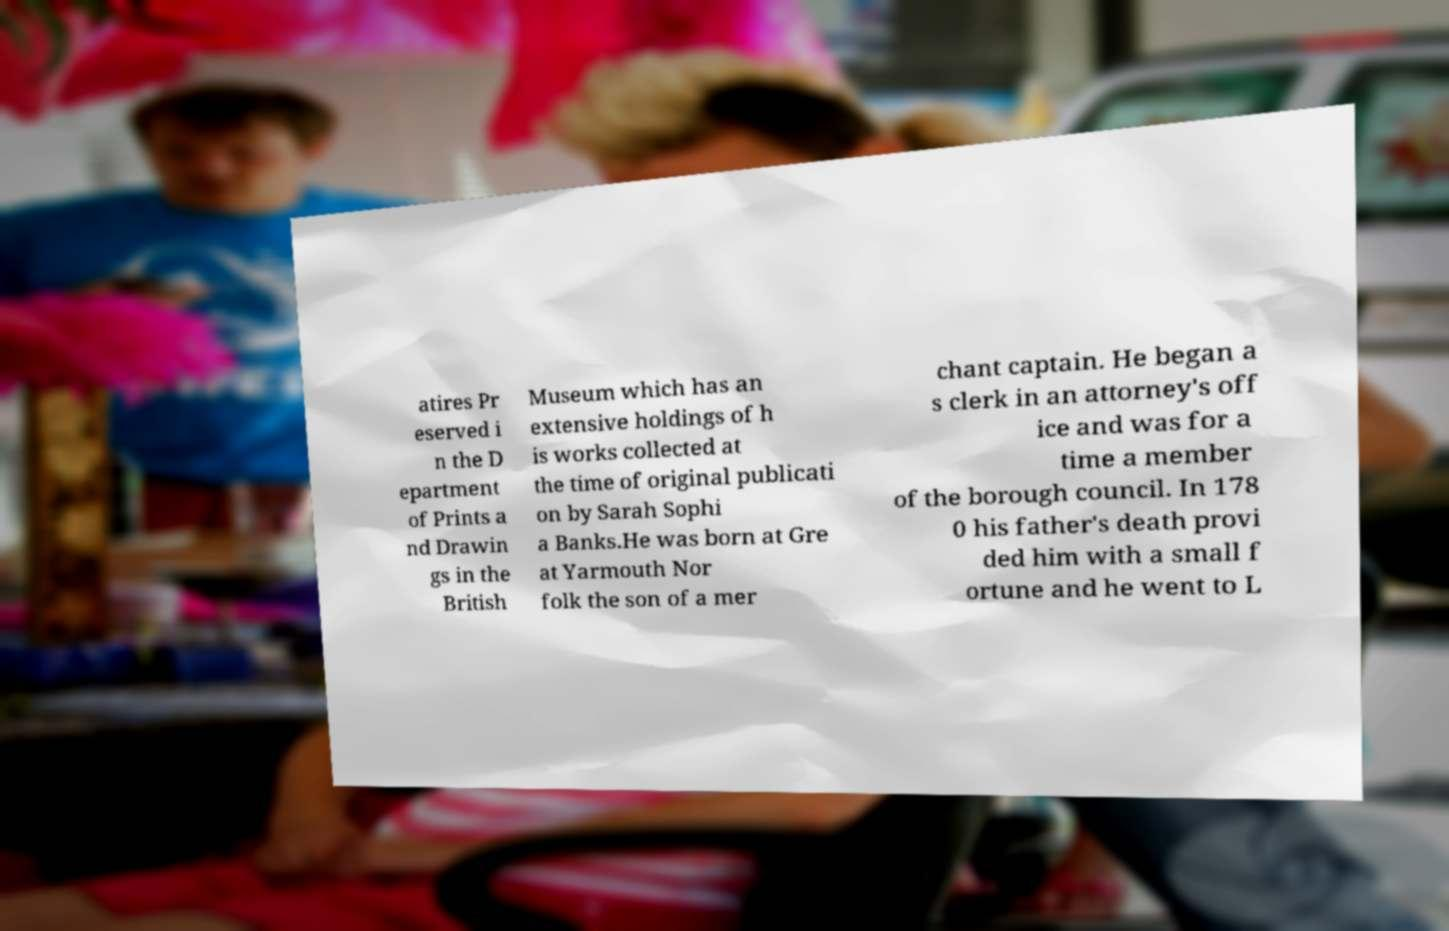For documentation purposes, I need the text within this image transcribed. Could you provide that? atires Pr eserved i n the D epartment of Prints a nd Drawin gs in the British Museum which has an extensive holdings of h is works collected at the time of original publicati on by Sarah Sophi a Banks.He was born at Gre at Yarmouth Nor folk the son of a mer chant captain. He began a s clerk in an attorney's off ice and was for a time a member of the borough council. In 178 0 his father's death provi ded him with a small f ortune and he went to L 